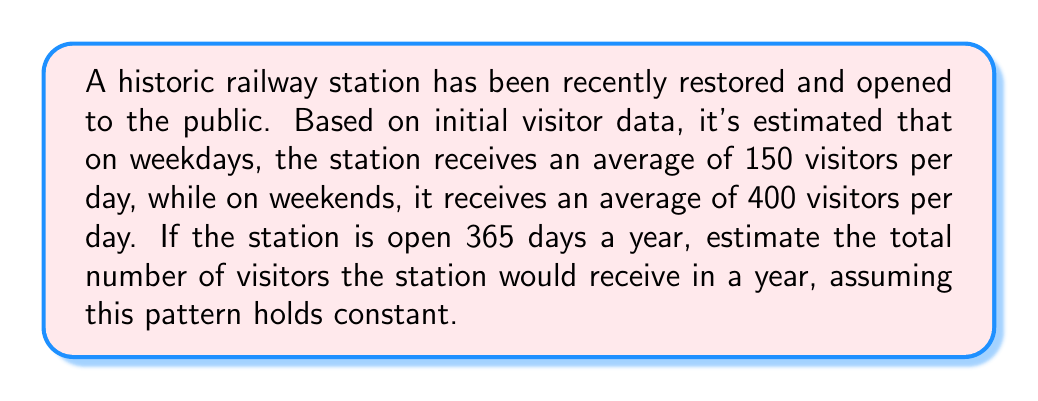Teach me how to tackle this problem. To solve this problem, we need to follow these steps:

1. Calculate the number of weekdays and weekend days in a year:
   - There are 52 weeks in a year
   - Each week has 5 weekdays and 2 weekend days
   - Weekdays: $5 \times 52 = 260$ days
   - Weekend days: $2 \times 52 = 104$ days
   - Total: $260 + 104 = 364$ days (We'll account for the extra day later)

2. Calculate the number of visitors for weekdays:
   $$ \text{Weekday visitors} = 260 \times 150 = 39,000 $$

3. Calculate the number of visitors for weekend days:
   $$ \text{Weekend visitors} = 104 \times 400 = 41,600 $$

4. Sum up the weekday and weekend visitors:
   $$ \text{Total visitors} = 39,000 + 41,600 = 80,600 $$

5. Account for the extra day (365th day):
   - We can assume this day has the average daily visitors of $(150 \times 5 + 400 \times 2) / 7 \approx 221$ visitors

6. Add the extra day's visitors to the total:
   $$ \text{Final total} = 80,600 + 221 = 80,821 $$

Therefore, the estimated number of visitors to the restored railway station in a year is approximately 80,821.
Answer: Approximately 80,821 visitors per year 